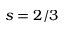Convert formula to latex. <formula><loc_0><loc_0><loc_500><loc_500>s = 2 / 3</formula> 